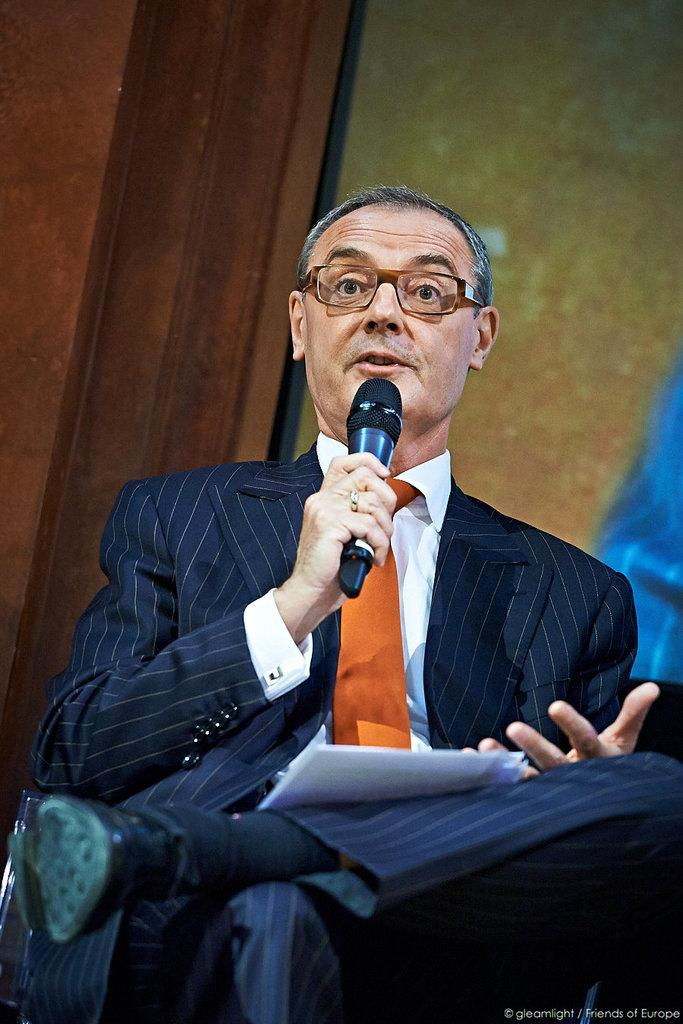What is the man in the image doing? The man is talking. What is the man wearing in the image? The man is wearing a dark blue suit and an orange tie. What object is the man holding in the image? The man is holding a microphone. Can you describe the man's hand accessories in the image? The man has a ring on his right hand. What position is the man in while talking? The man is sitting on a chair. What type of humor is the man using while talking on the dock in the image? There is no dock present in the image, and the man's sense of humor cannot be determined from the image. What is the man feeling shame about in the image? There is no indication of shame in the image, and the man's feelings cannot be determined from the image. 